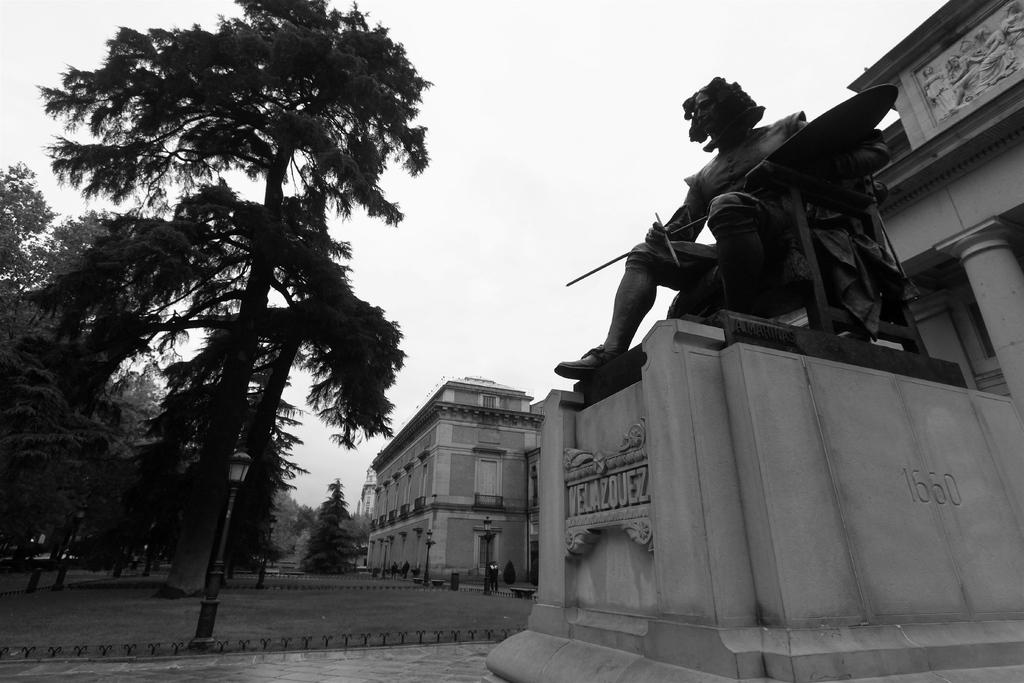What is the main subject in the image? There is a statue in the image. What can be seen in the background of the image? There are buildings, poles, trees, and lights in the background of the image. Where is the guide leading the group in the image? There is no guide or group present in the image; it only features a statue and background elements. What type of jar is visible on the statue's hand in the image? There is no jar present on the statue's hand in the image. 